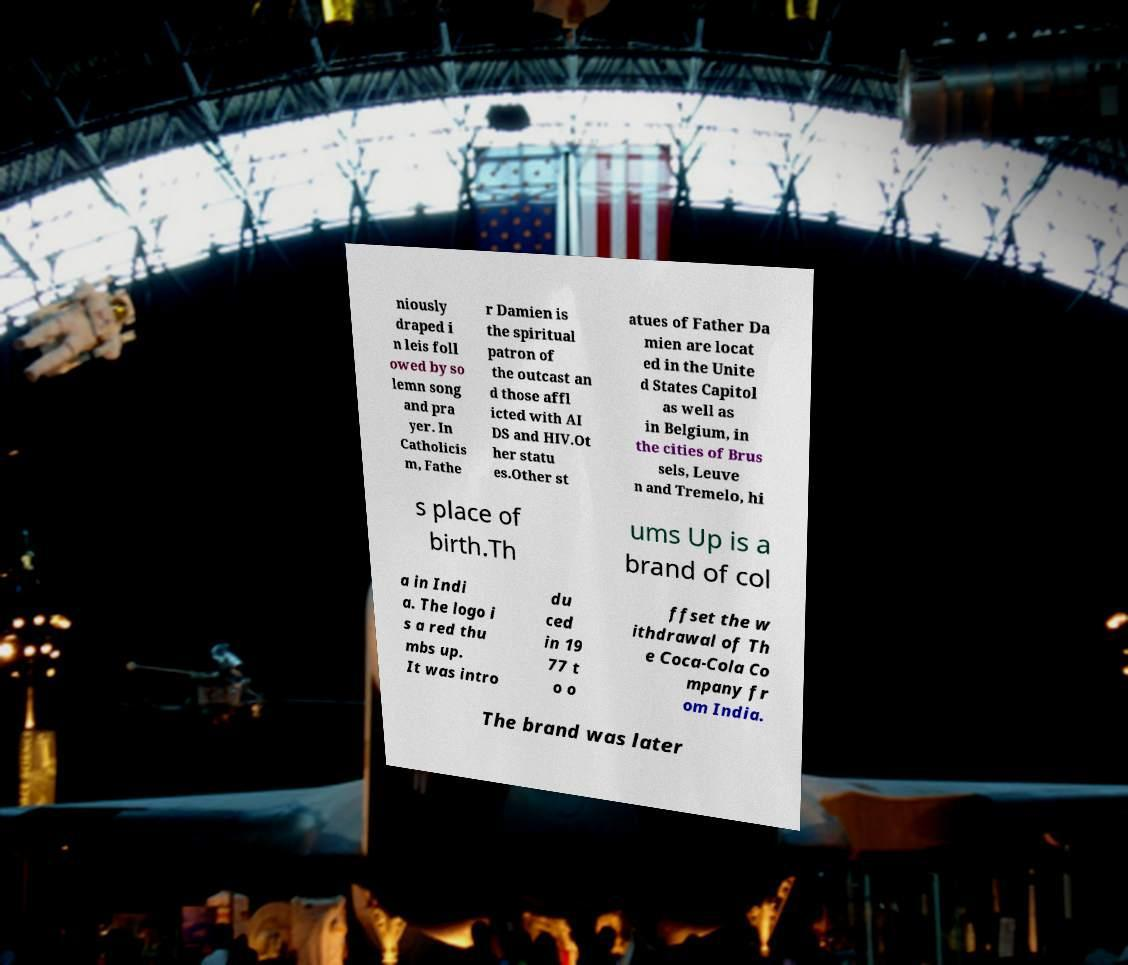For documentation purposes, I need the text within this image transcribed. Could you provide that? niously draped i n leis foll owed by so lemn song and pra yer. In Catholicis m, Fathe r Damien is the spiritual patron of the outcast an d those affl icted with AI DS and HIV.Ot her statu es.Other st atues of Father Da mien are locat ed in the Unite d States Capitol as well as in Belgium, in the cities of Brus sels, Leuve n and Tremelo, hi s place of birth.Th ums Up is a brand of col a in Indi a. The logo i s a red thu mbs up. It was intro du ced in 19 77 t o o ffset the w ithdrawal of Th e Coca-Cola Co mpany fr om India. The brand was later 